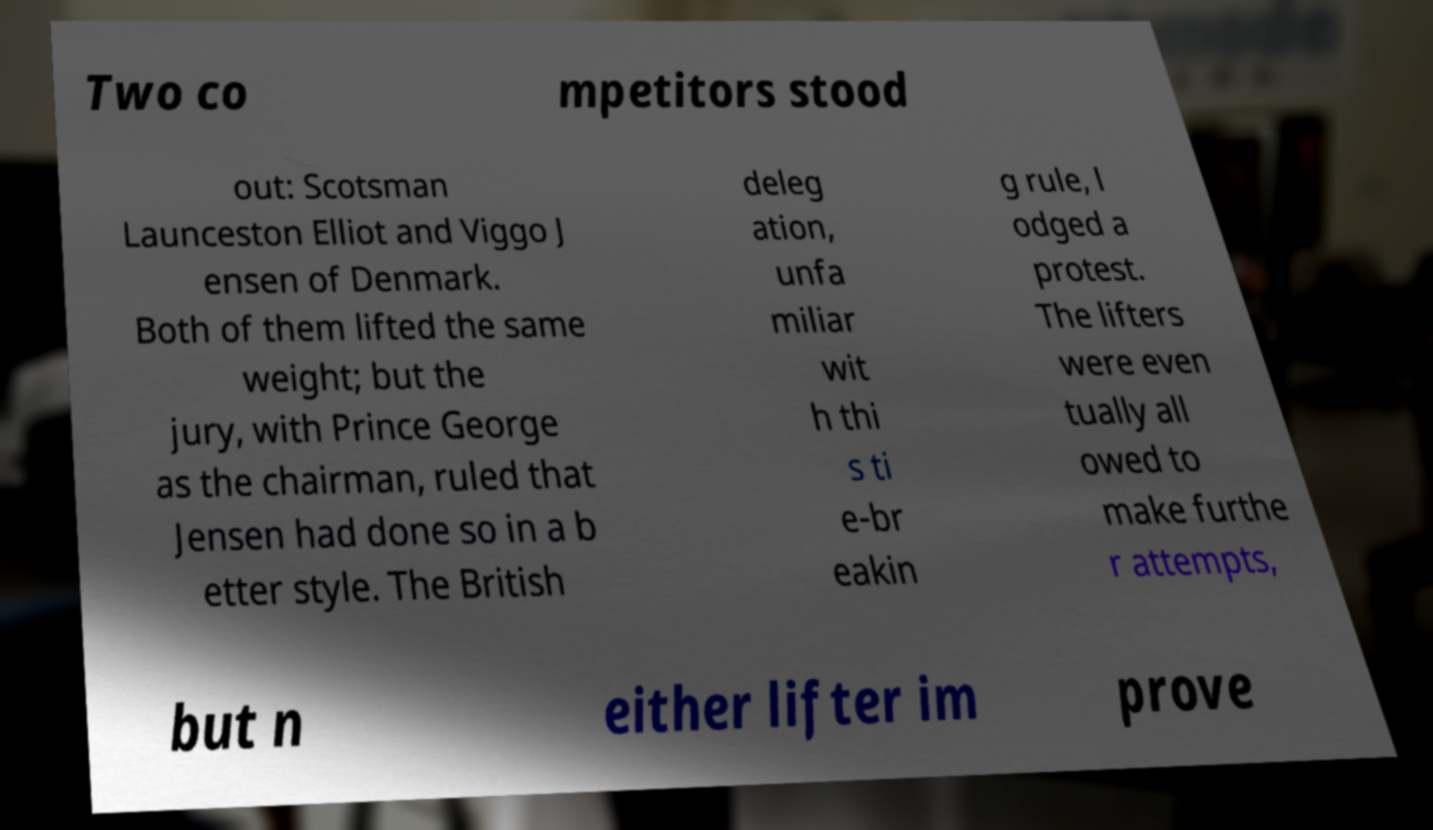Can you read and provide the text displayed in the image?This photo seems to have some interesting text. Can you extract and type it out for me? Two co mpetitors stood out: Scotsman Launceston Elliot and Viggo J ensen of Denmark. Both of them lifted the same weight; but the jury, with Prince George as the chairman, ruled that Jensen had done so in a b etter style. The British deleg ation, unfa miliar wit h thi s ti e-br eakin g rule, l odged a protest. The lifters were even tually all owed to make furthe r attempts, but n either lifter im prove 